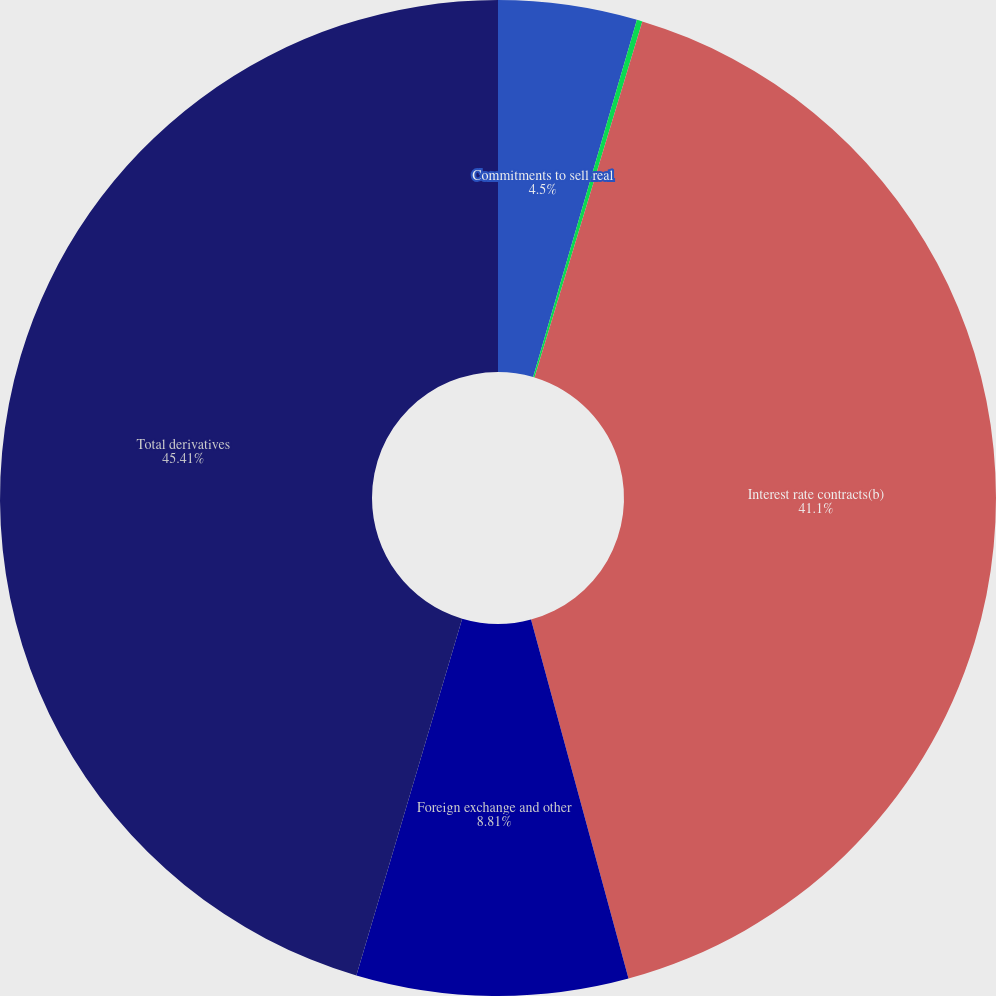Convert chart to OTSL. <chart><loc_0><loc_0><loc_500><loc_500><pie_chart><fcel>Commitments to sell real<fcel>Mortgage-related commitments<fcel>Interest rate contracts(b)<fcel>Foreign exchange and other<fcel>Total derivatives<nl><fcel>4.5%<fcel>0.18%<fcel>41.1%<fcel>8.81%<fcel>45.41%<nl></chart> 